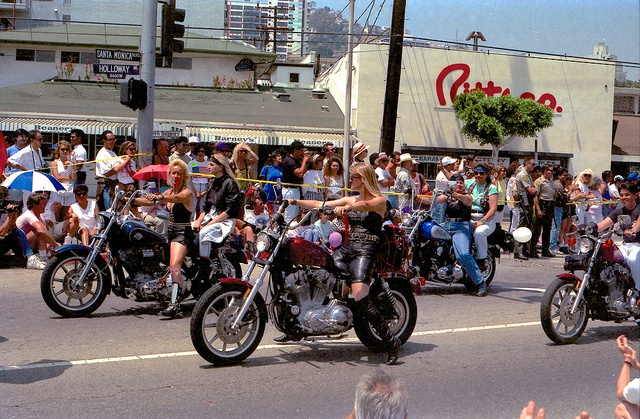Describe the objects in this image and their specific colors. I can see people in gray, black, maroon, and darkgray tones, motorcycle in gray, black, darkgray, and maroon tones, motorcycle in gray, black, maroon, and darkgray tones, motorcycle in gray, black, darkgray, and maroon tones, and people in gray, black, brown, and maroon tones in this image. 